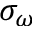Convert formula to latex. <formula><loc_0><loc_0><loc_500><loc_500>\sigma _ { \omega }</formula> 